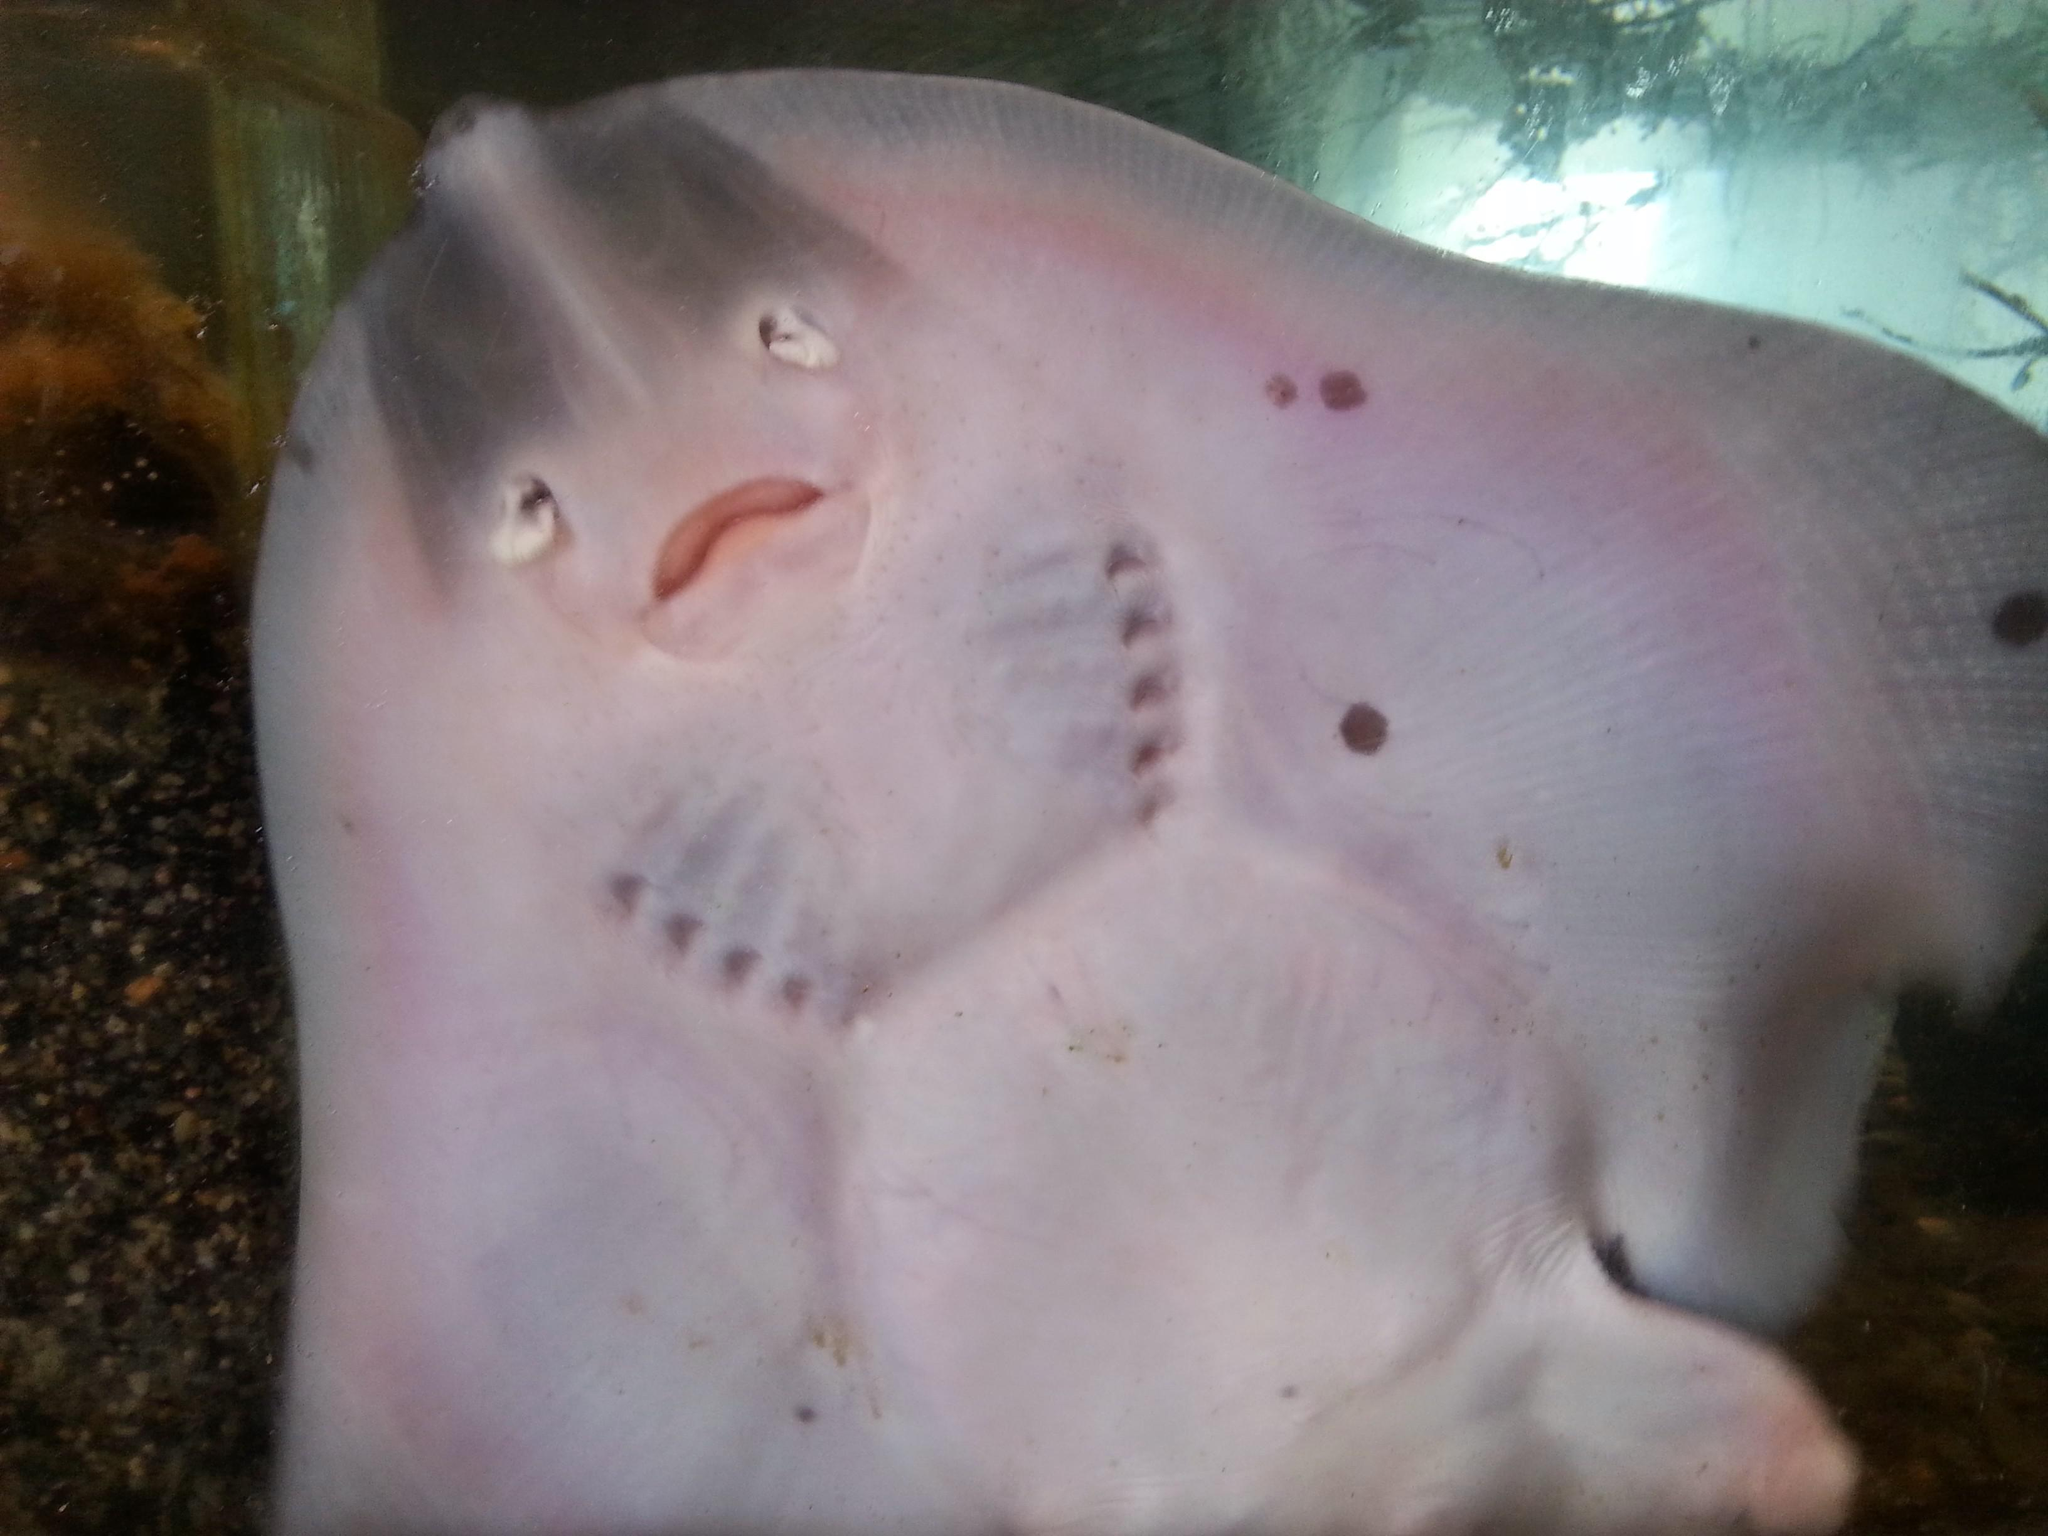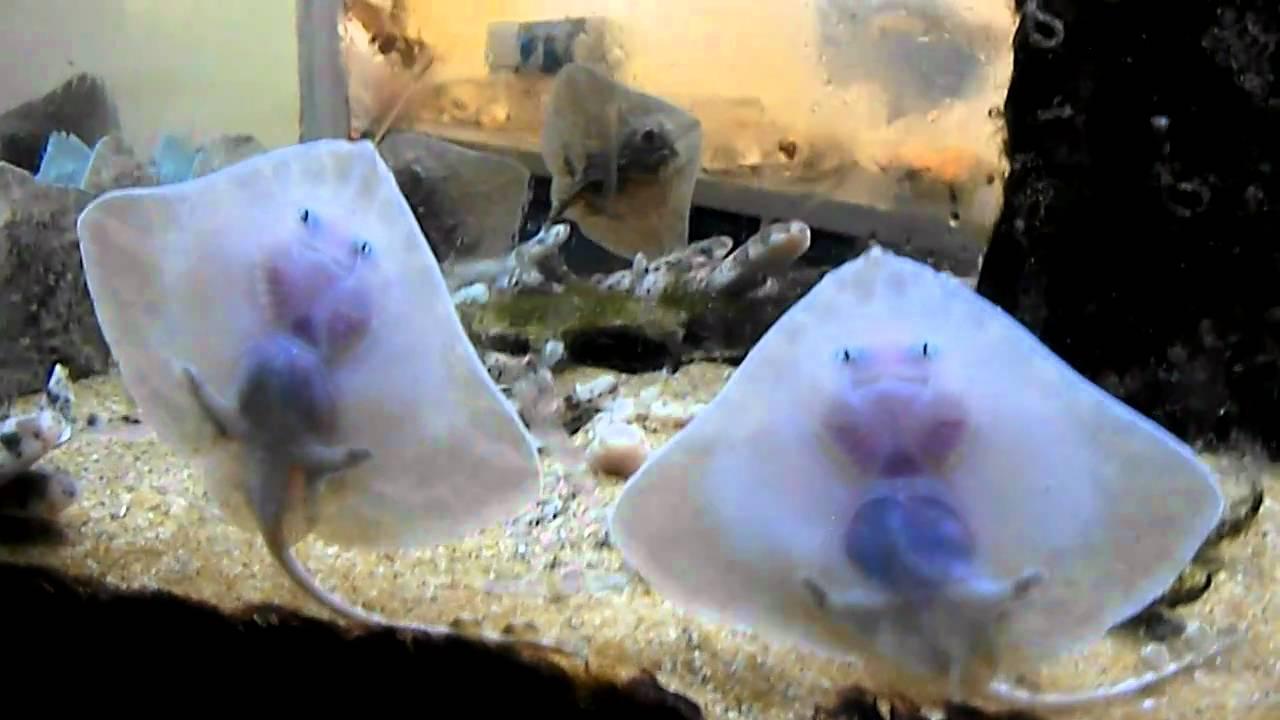The first image is the image on the left, the second image is the image on the right. Evaluate the accuracy of this statement regarding the images: "The left image contains just one stingray.". Is it true? Answer yes or no. Yes. The first image is the image on the left, the second image is the image on the right. Evaluate the accuracy of this statement regarding the images: "The left and right image contains a total of five stingrays.". Is it true? Answer yes or no. Yes. 